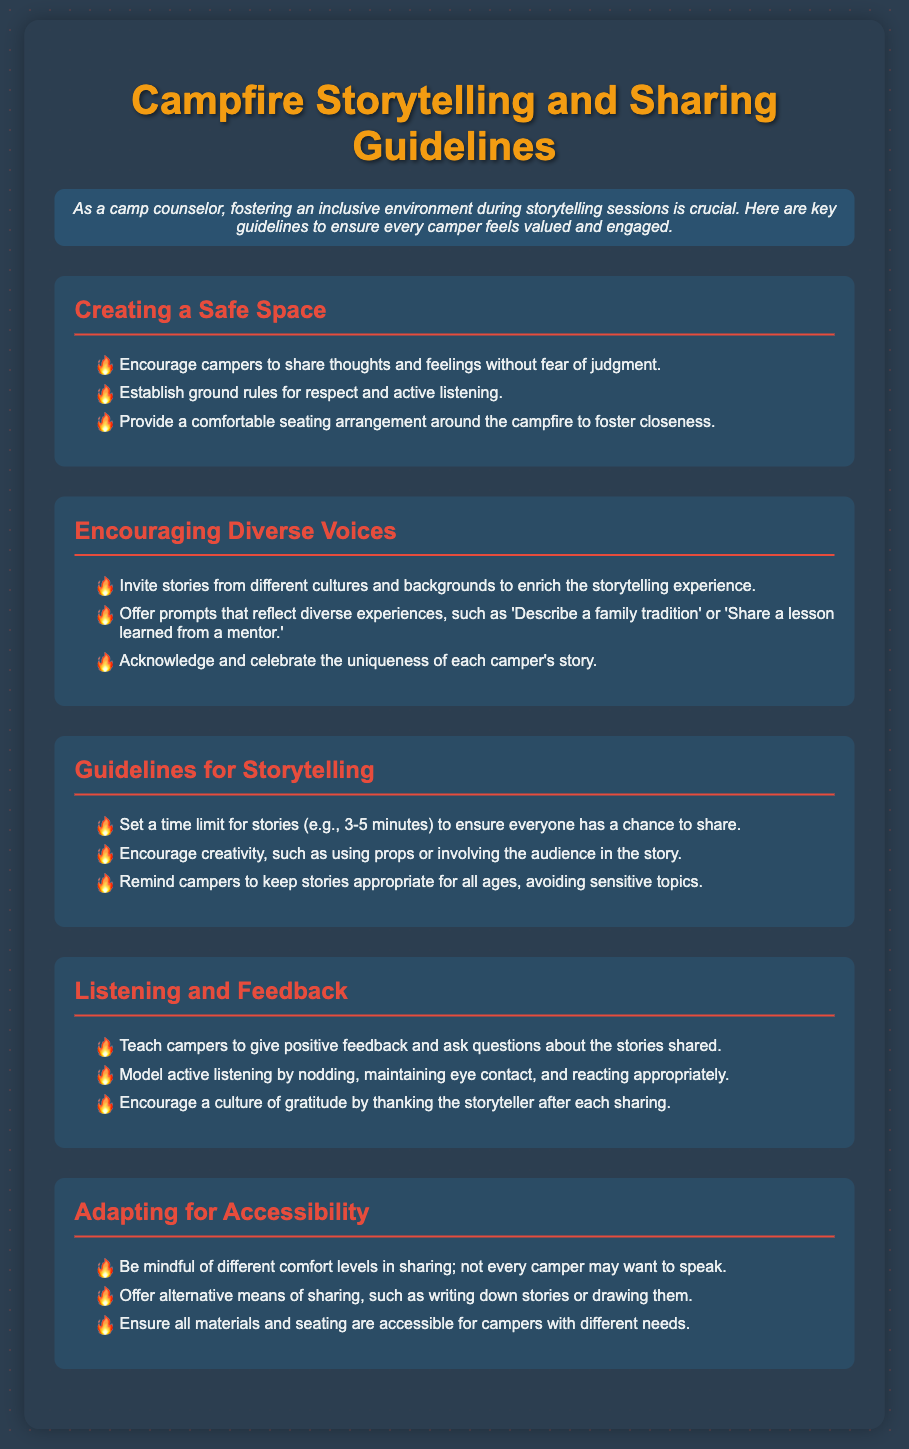What is the document's title? The title of the document is displayed prominently at the top of the page.
Answer: Campfire Storytelling and Sharing Guidelines What color is used for the headings? The headings in the document have a specific color that is consistently applied throughout.
Answer: E74C3C How many sections are there in the guidelines? The document is divided into several clearly defined sections, each addressed individually.
Answer: Five What is one guideline for creating a safe space? The document lists various important guidelines for establishing a welcoming storytelling environment.
Answer: Encourage campers to share thoughts and feelings without fear of judgment What should campers do after a story is shared? The document emphasizes the importance of acknowledging storytellers through a certain behavior after sharing.
Answer: Thank the storyteller What is one way to ensure accessibility for campers? The document suggests specific actions to accommodate different needs and facilitate participation.
Answer: Offer alternative means of sharing 